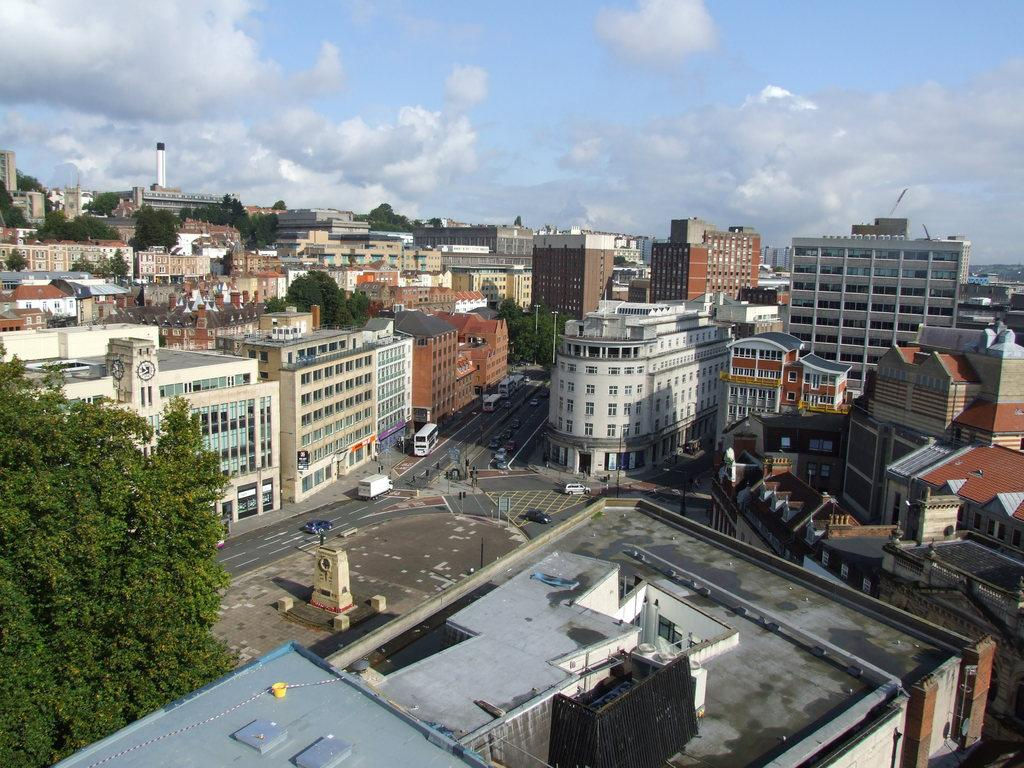What type of structures can be seen in the image? There are buildings in the image. What else is present in the image besides buildings? There is a road, vehicles, poles, and the sky is visible in the image. What can be seen in the sky in the image? Clouds are present in the sky. How many chairs can be seen in the image? There are no chairs present in the image. Is there a note attached to any of the vehicles in the image? There is no mention of a note in the image; only vehicles, buildings, a road, poles, and the sky with clouds are visible. 